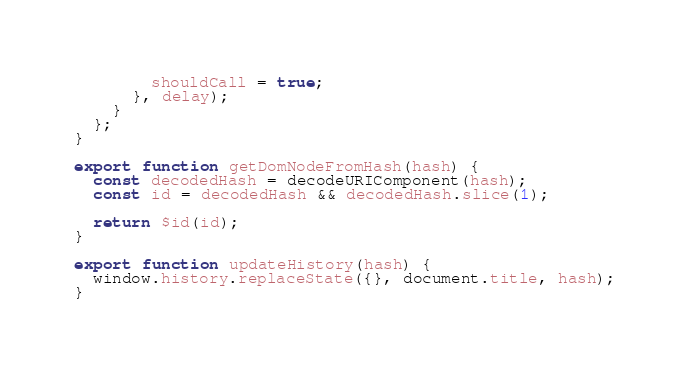Convert code to text. <code><loc_0><loc_0><loc_500><loc_500><_JavaScript_>        shouldCall = true;
      }, delay);
    }
  };
}

export function getDomNodeFromHash(hash) {
  const decodedHash = decodeURIComponent(hash);
  const id = decodedHash && decodedHash.slice(1);

  return $id(id);
}

export function updateHistory(hash) {
  window.history.replaceState({}, document.title, hash);
}
</code> 